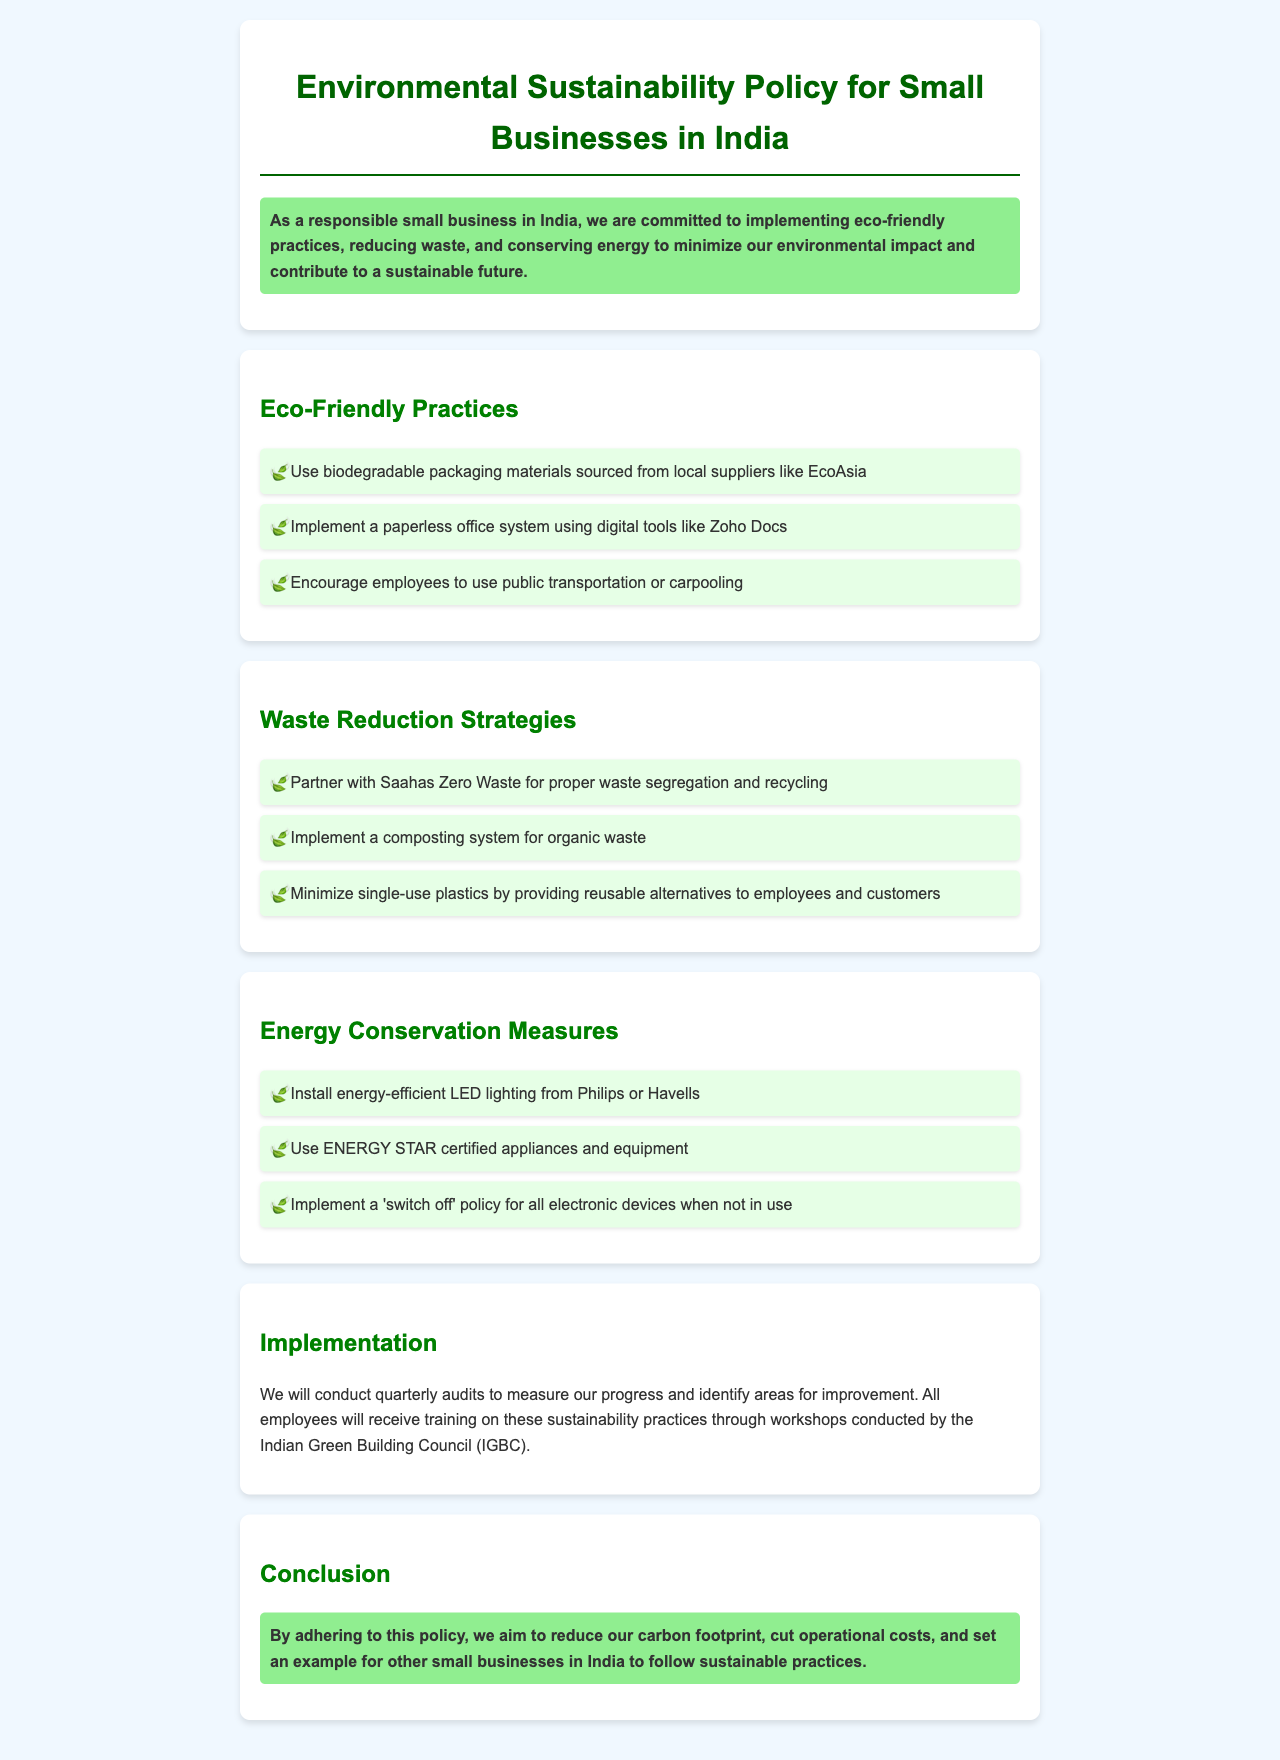what is the title of the document? The title of the document can be found in the header section, which states the main focus of the policy.
Answer: Environmental Sustainability Policy for Small Businesses in India what is the commitment mentioned in the document? The commitment is outlined in the introduction, highlighting the business's responsibility towards environmental practices.
Answer: implementing eco-friendly practices how often will audits be conducted? The frequency of audits is mentioned in the implementation section, providing insights into the review process of the policy.
Answer: quarterly which organization is mentioned for training employees? The organization is referenced in the implementation section as responsible for conducting workshops on sustainability practices.
Answer: Indian Green Building Council what is one energy-efficient lighting option recommended? One option is indicated under energy conservation measures, reflecting advice on lighting technology.
Answer: LED lighting from Philips or Havells what waste reduction partner is mentioned? The partner organization is included in the strategies section, showcasing collaboration for effective waste management.
Answer: Saahas Zero Waste what is a strategy to minimize single-use plastics? A specific approach is outlined in the waste reduction strategies section to address the use of plastics.
Answer: providing reusable alternatives what type of packaging materials should be used? The document specifies a particular type of material that aligns with eco-friendly practices in the packaging section.
Answer: biodegradable packaging materials 